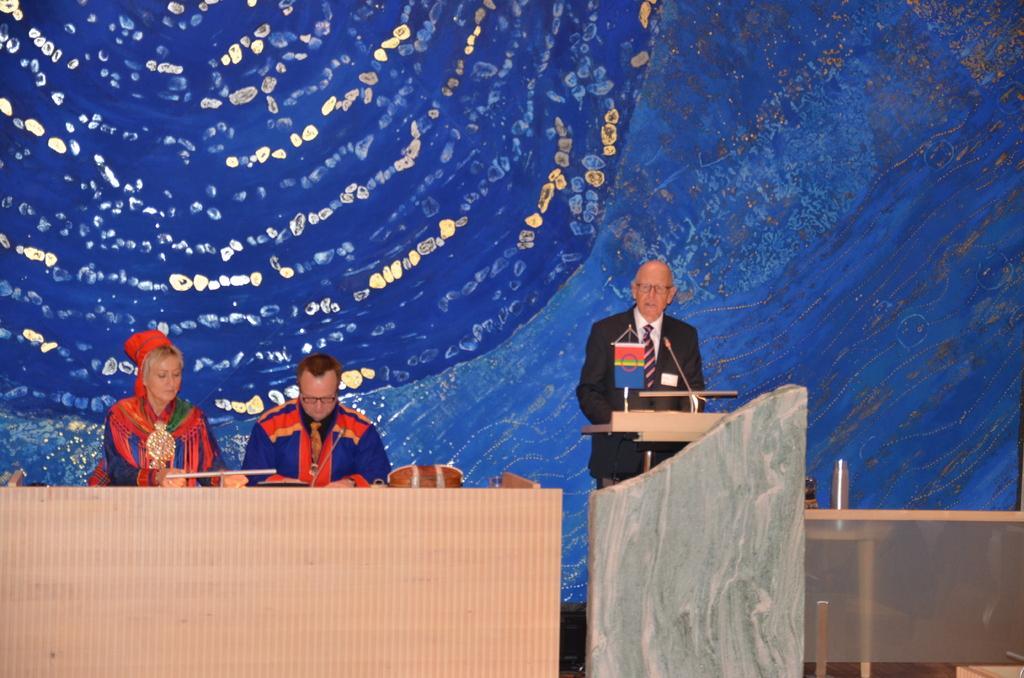Can you describe this image briefly? In this image at front there is a table. Behind the table there are two persons sitting on the chairs. Beside the table there is a dais and on top of the days there is a mike. Behind the days there is a person standing. At the back side there is a wall. 